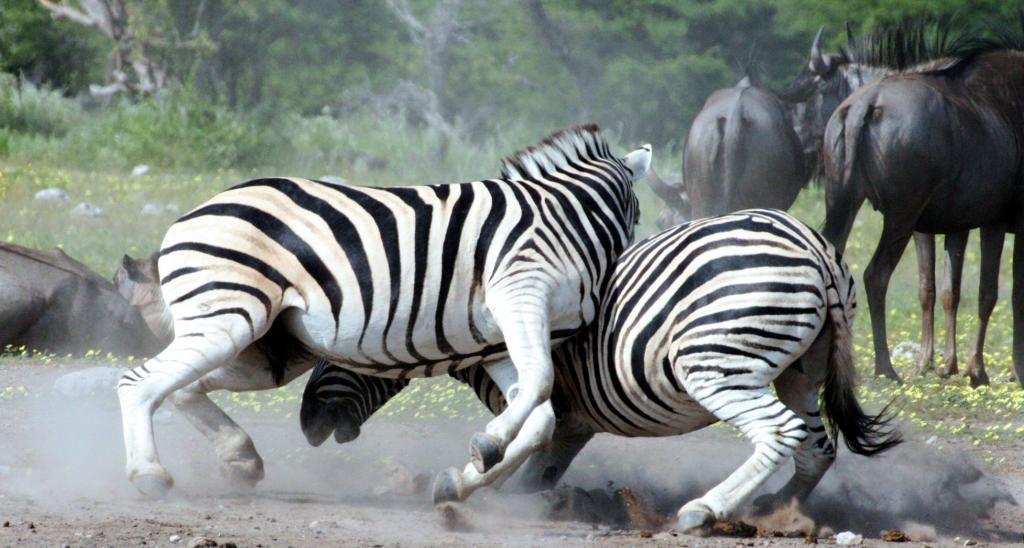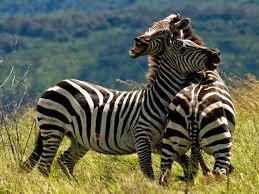The first image is the image on the left, the second image is the image on the right. Considering the images on both sides, is "A taller standing zebra is left of a smaller standing zebra in one image, and the other image shows a zebra standing with its body turned rightward." valid? Answer yes or no. No. The first image is the image on the left, the second image is the image on the right. Given the left and right images, does the statement "There is more than one species of animal present." hold true? Answer yes or no. Yes. 